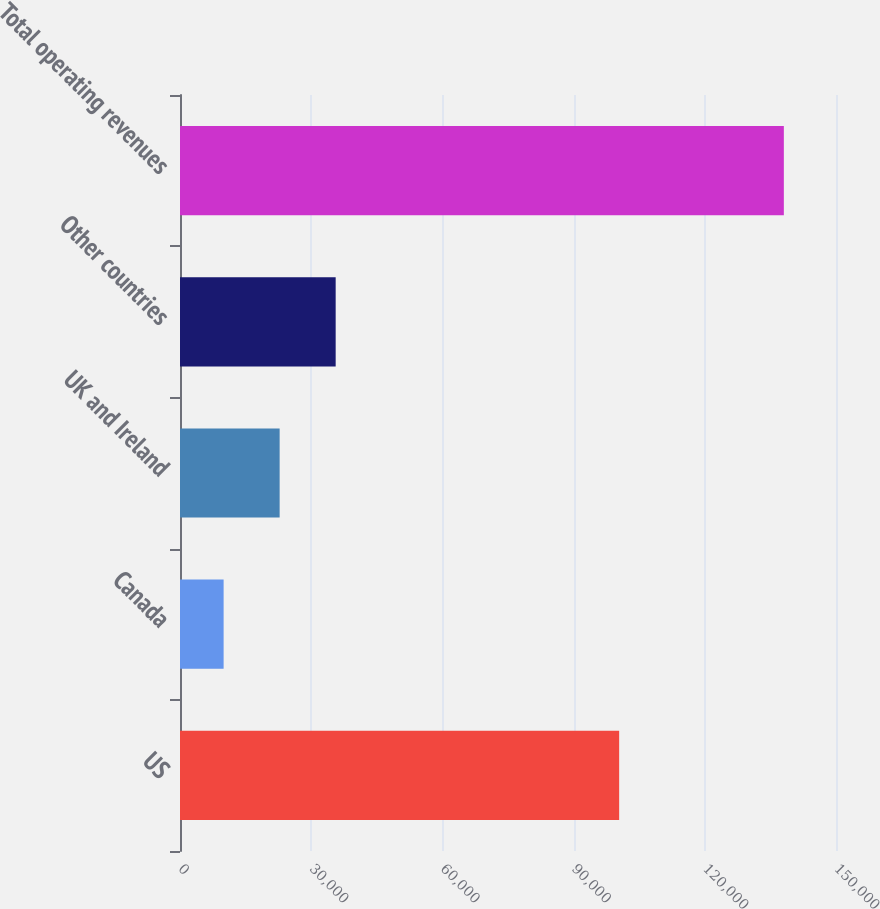<chart> <loc_0><loc_0><loc_500><loc_500><bar_chart><fcel>US<fcel>Canada<fcel>UK and Ireland<fcel>Other countries<fcel>Total operating revenues<nl><fcel>100418<fcel>9974<fcel>22784<fcel>35594<fcel>138074<nl></chart> 